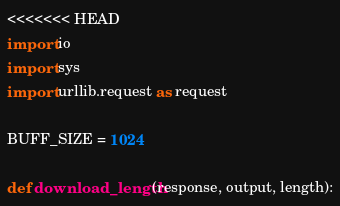<code> <loc_0><loc_0><loc_500><loc_500><_Python_><<<<<<< HEAD
import io
import sys
import urllib.request as request

BUFF_SIZE = 1024

def download_length(response, output, length):</code> 